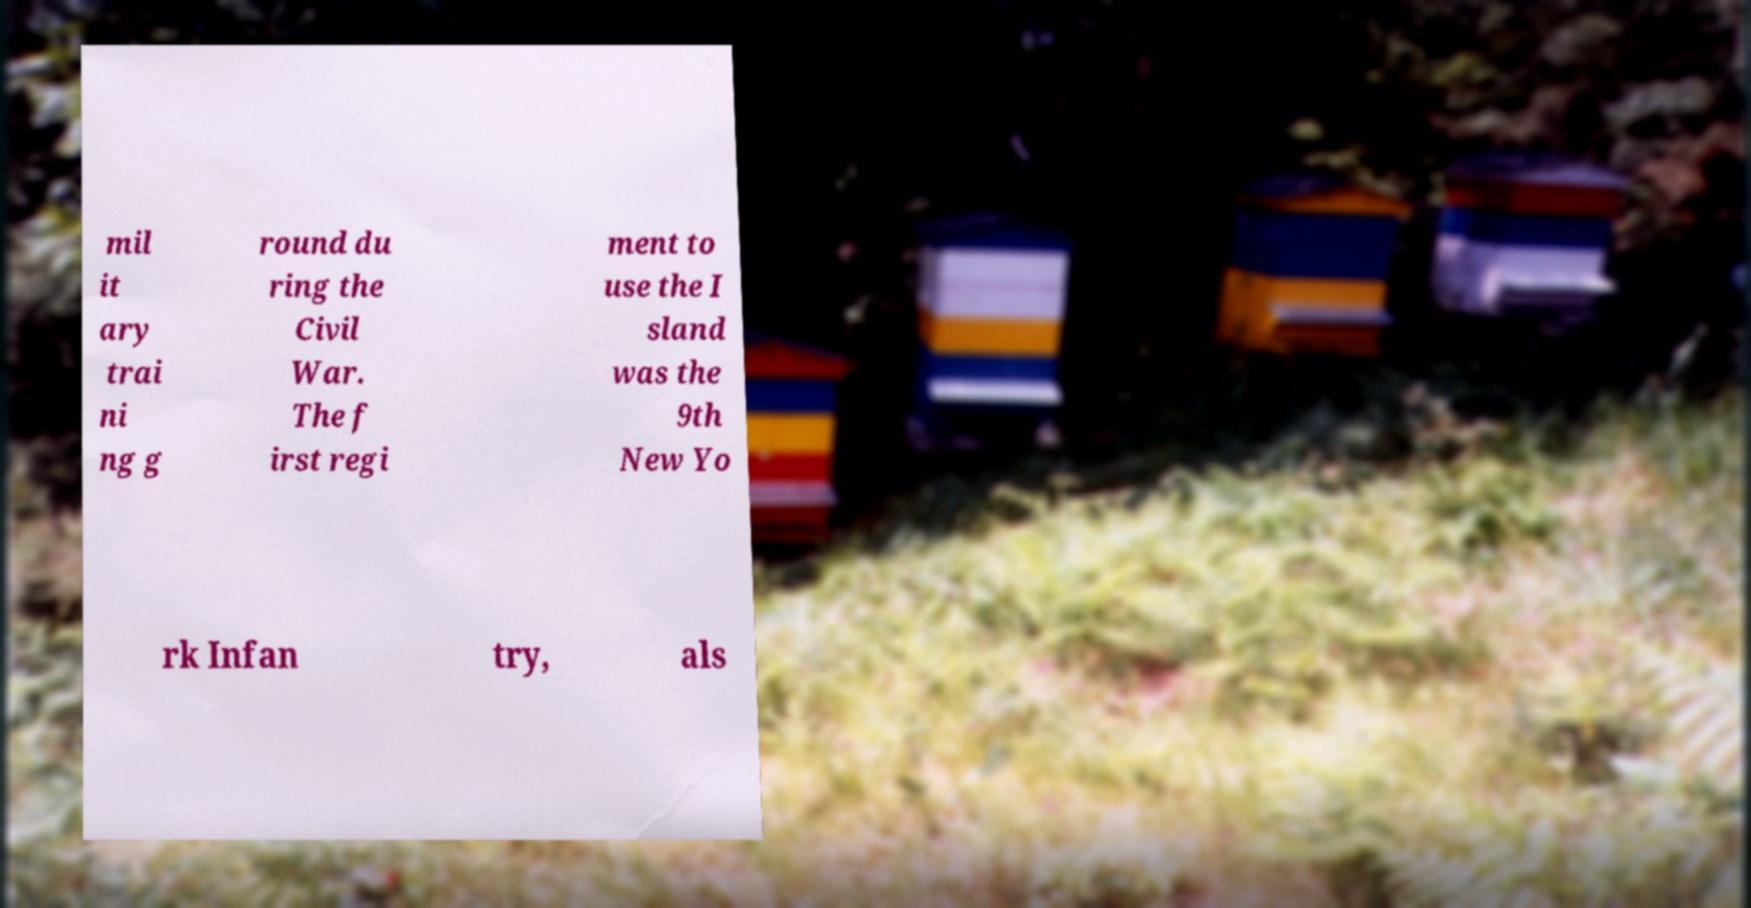For documentation purposes, I need the text within this image transcribed. Could you provide that? mil it ary trai ni ng g round du ring the Civil War. The f irst regi ment to use the I sland was the 9th New Yo rk Infan try, als 